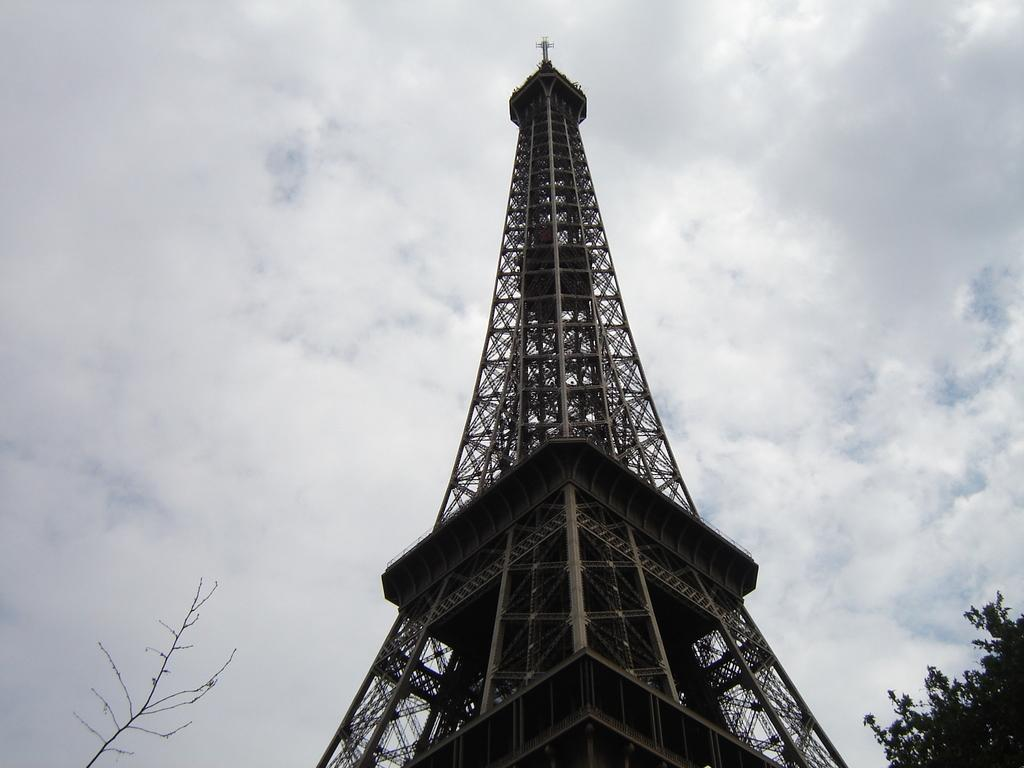What famous landmark is present in the image? There is an Eiffel Tower in the image. What type of natural vegetation can be seen in the image? There are trees in the image. What is the condition of the sky in the image? The sky is cloudy in the image. What type of cork can be seen floating in the image? There is no cork present in the image. What part of a farm animal is depicted in the image? There is no part of a farm animal, such as a yoke, present in the image. 